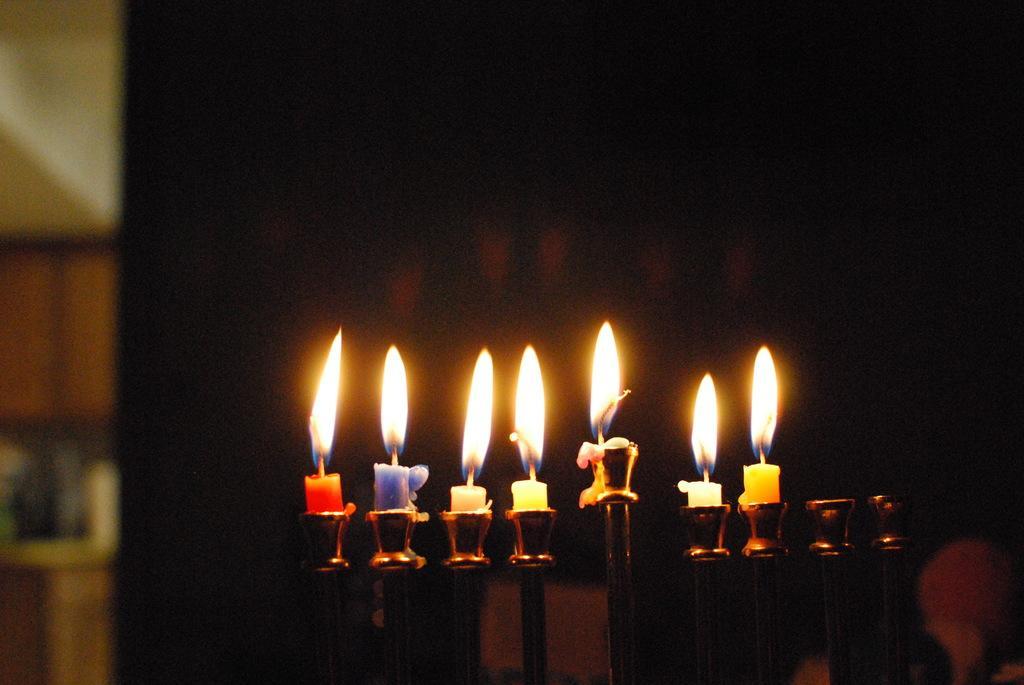Describe this image in one or two sentences. In this image in the foreground there are some candles and some candle stands, and there is a blurry background. 